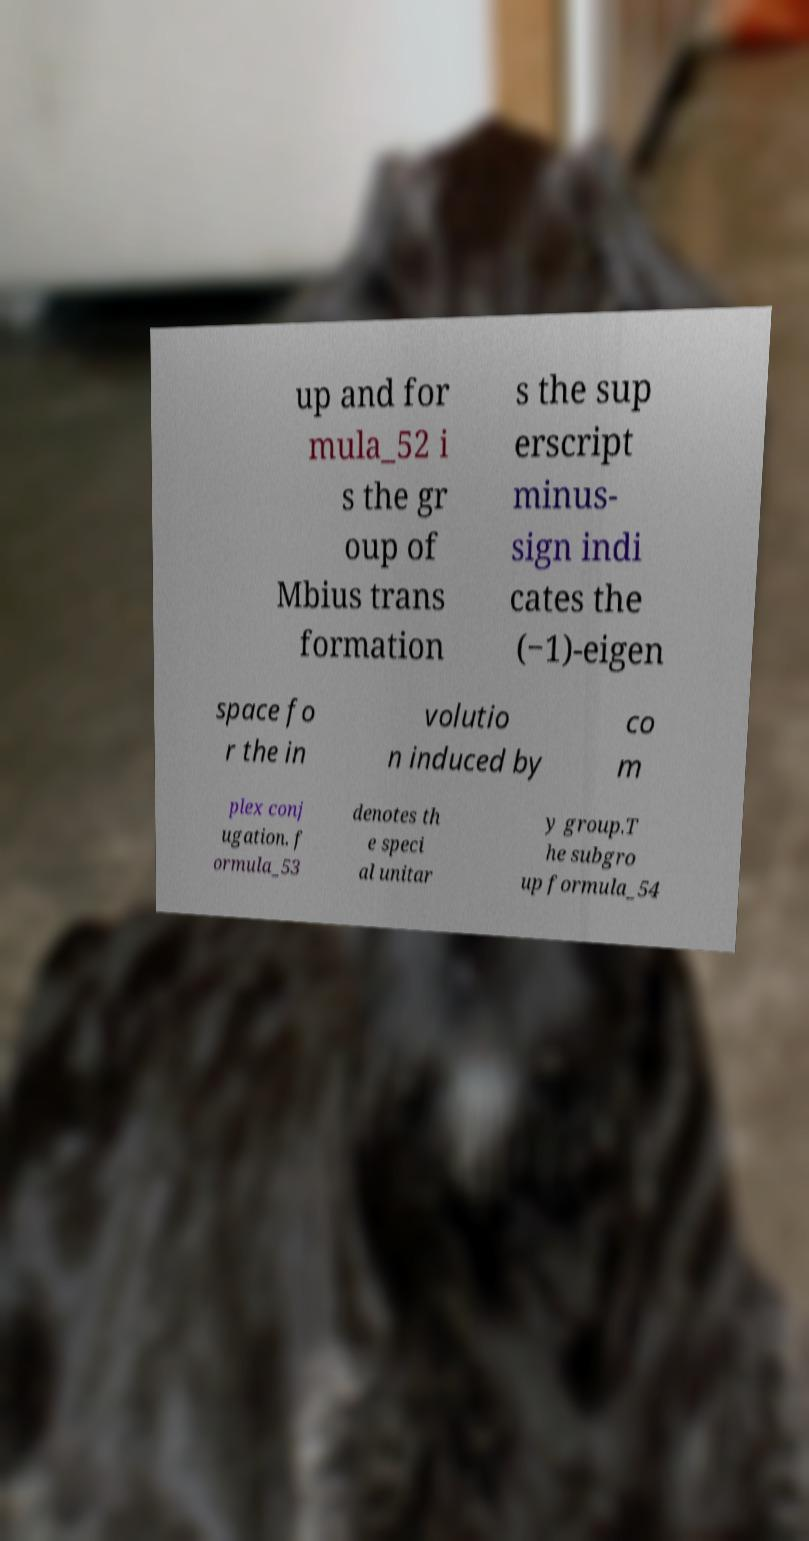Can you read and provide the text displayed in the image?This photo seems to have some interesting text. Can you extract and type it out for me? up and for mula_52 i s the gr oup of Mbius trans formation s the sup erscript minus- sign indi cates the (−1)-eigen space fo r the in volutio n induced by co m plex conj ugation. f ormula_53 denotes th e speci al unitar y group.T he subgro up formula_54 